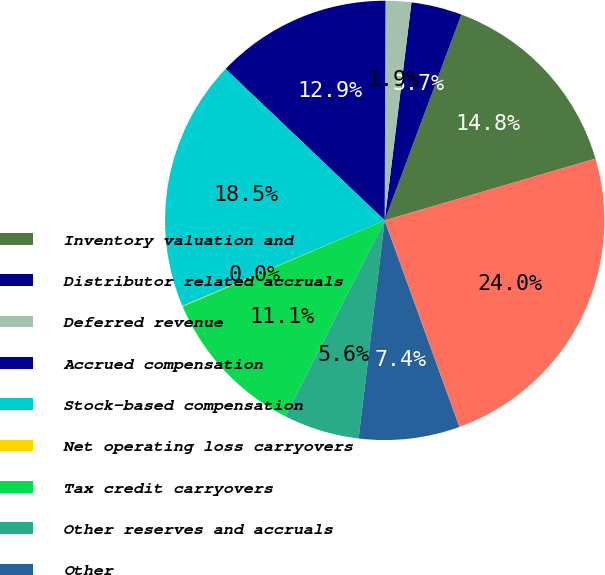<chart> <loc_0><loc_0><loc_500><loc_500><pie_chart><fcel>Inventory valuation and<fcel>Distributor related accruals<fcel>Deferred revenue<fcel>Accrued compensation<fcel>Stock-based compensation<fcel>Net operating loss carryovers<fcel>Tax credit carryovers<fcel>Other reserves and accruals<fcel>Other<fcel>Total deferred tax assets<nl><fcel>14.79%<fcel>3.73%<fcel>1.89%<fcel>12.95%<fcel>18.48%<fcel>0.05%<fcel>11.11%<fcel>5.58%<fcel>7.42%<fcel>24.01%<nl></chart> 